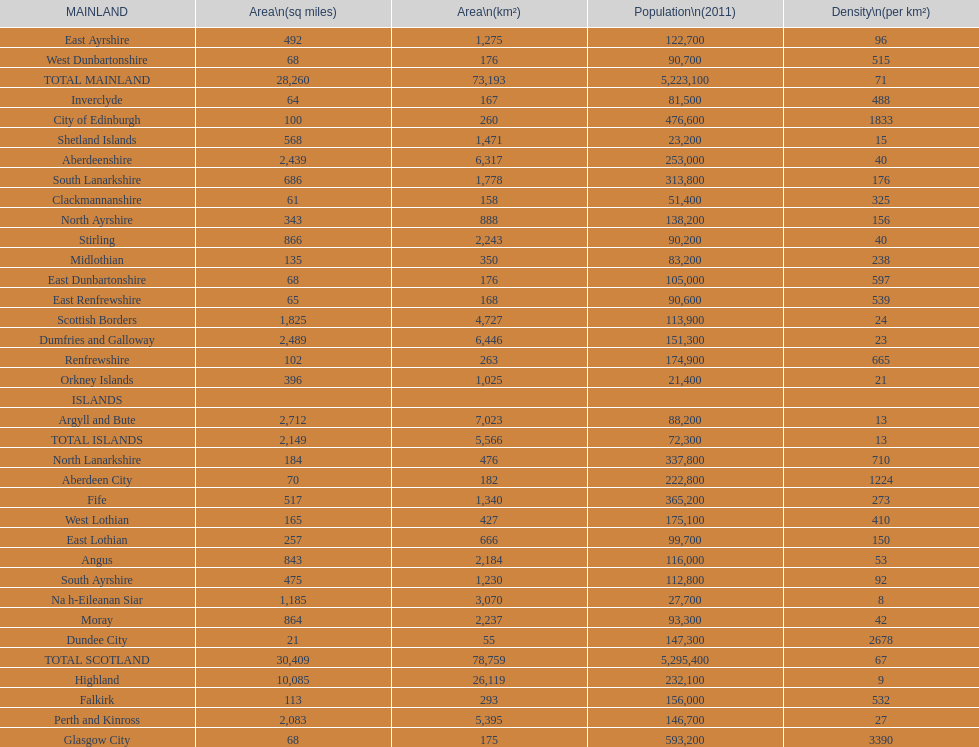What number of mainlands have populations under 100,000? 9. 